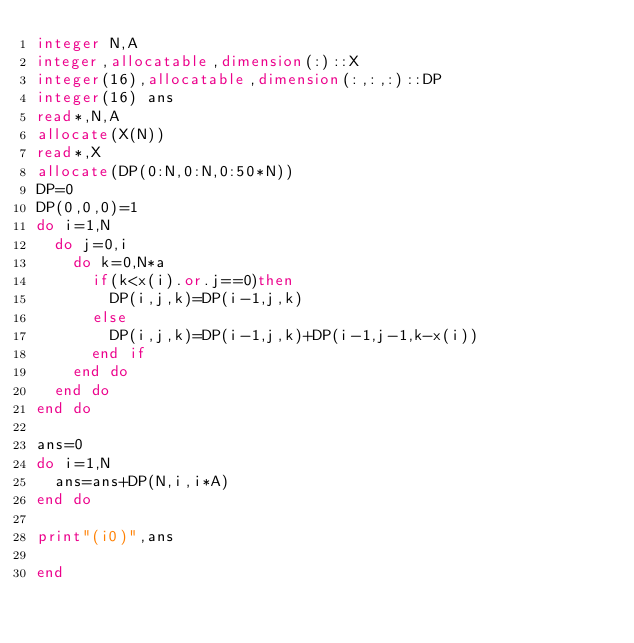<code> <loc_0><loc_0><loc_500><loc_500><_FORTRAN_>integer N,A
integer,allocatable,dimension(:)::X
integer(16),allocatable,dimension(:,:,:)::DP
integer(16) ans
read*,N,A
allocate(X(N))
read*,X
allocate(DP(0:N,0:N,0:50*N))
DP=0
DP(0,0,0)=1
do i=1,N
  do j=0,i
    do k=0,N*a
      if(k<x(i).or.j==0)then
        DP(i,j,k)=DP(i-1,j,k)
      else
        DP(i,j,k)=DP(i-1,j,k)+DP(i-1,j-1,k-x(i))
      end if
    end do
  end do
end do

ans=0
do i=1,N
  ans=ans+DP(N,i,i*A)
end do

print"(i0)",ans

end
</code> 